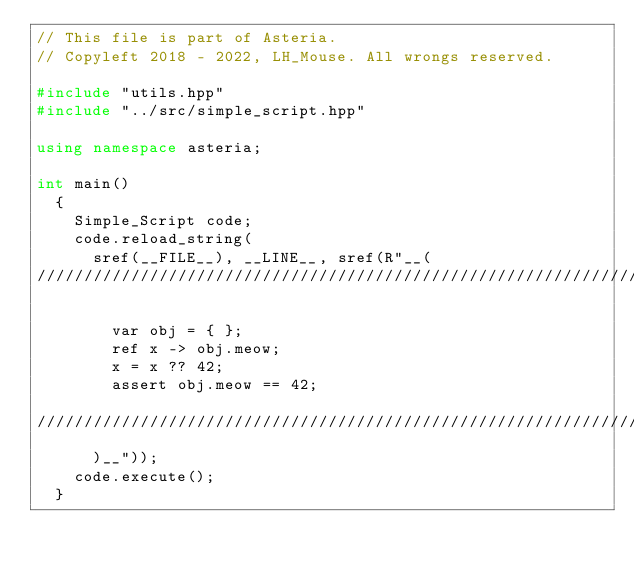<code> <loc_0><loc_0><loc_500><loc_500><_C++_>// This file is part of Asteria.
// Copyleft 2018 - 2022, LH_Mouse. All wrongs reserved.

#include "utils.hpp"
#include "../src/simple_script.hpp"

using namespace asteria;

int main()
  {
    Simple_Script code;
    code.reload_string(
      sref(__FILE__), __LINE__, sref(R"__(
///////////////////////////////////////////////////////////////////////////////

        var obj = { };
        ref x -> obj.meow;
        x = x ?? 42;
        assert obj.meow == 42;

///////////////////////////////////////////////////////////////////////////////
      )__"));
    code.execute();
  }
</code> 